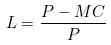<formula> <loc_0><loc_0><loc_500><loc_500>L = \frac { P - M C } { P }</formula> 